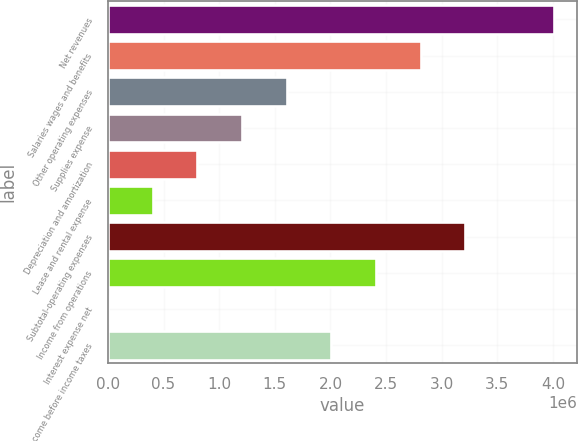<chart> <loc_0><loc_0><loc_500><loc_500><bar_chart><fcel>Net revenues<fcel>Salaries wages and benefits<fcel>Other operating expenses<fcel>Supplies expense<fcel>Depreciation and amortization<fcel>Lease and rental expense<fcel>Subtotal-operating expenses<fcel>Income from operations<fcel>Interest expense net<fcel>Income before income taxes<nl><fcel>4.01222e+06<fcel>2.80913e+06<fcel>1.60604e+06<fcel>1.20501e+06<fcel>803977<fcel>402947<fcel>3.21016e+06<fcel>2.4081e+06<fcel>1917<fcel>2.00707e+06<nl></chart> 